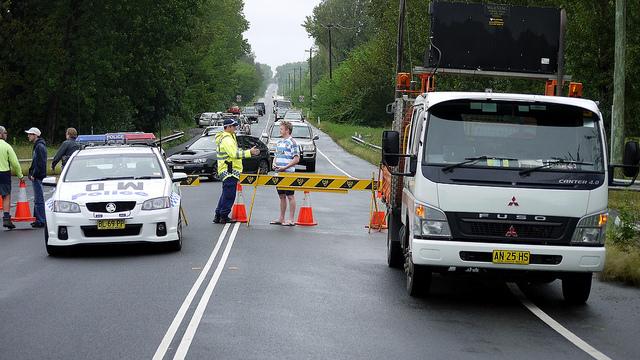Is there an accident?
Give a very brief answer. Yes. Is the truck on the right a city truck?
Be succinct. Yes. How many cones are there?
Answer briefly. 4. How many vehicles are in the photo?
Answer briefly. 10. 